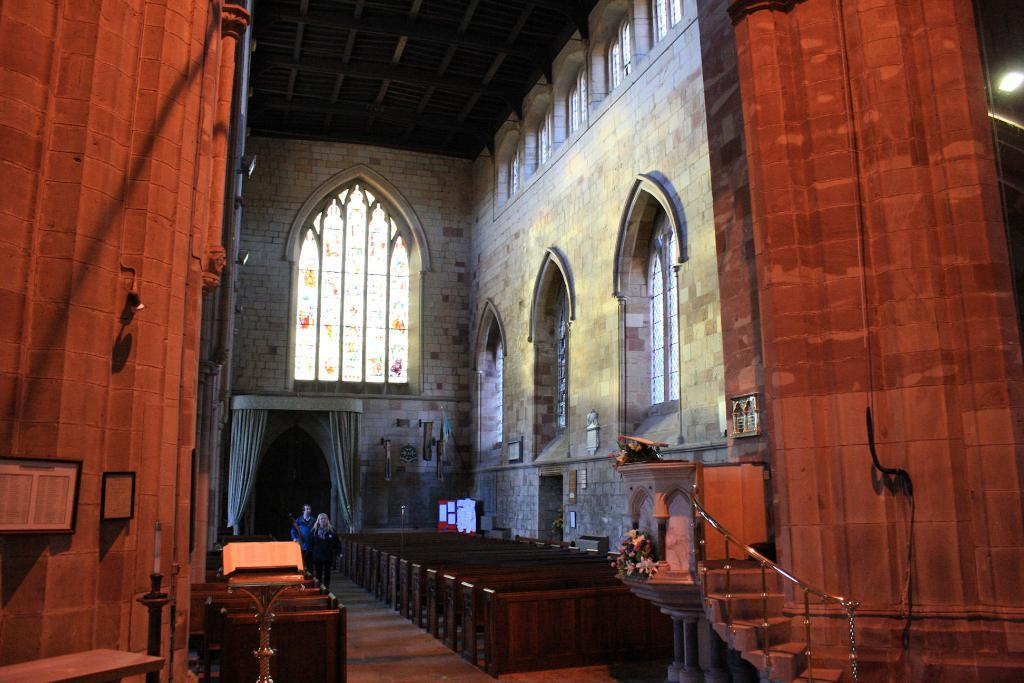What type of structure is in the image? There is a building in the image. What feature can be seen on the building? The building has glass windows. What architectural element is present in front of the building? There are stairs in front of the building. What type of vegetation is in front of the building? There are flowers in front of the building. What is the purpose of the stage in front of the building? The stage in front of the building might be used for performances or events. What type of furniture is visible in the image? There are tables visible in the image. What object can be seen in the image that might be used for displaying information? There is a board in the image. What are the two people in the image doing? Two people are walking in the image. How does the building blow in the wind in the image? The building does not blow in the wind in the image; it is a stationary structure. 